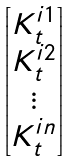Convert formula to latex. <formula><loc_0><loc_0><loc_500><loc_500>\begin{bmatrix} K ^ { i 1 } _ { t } \\ K ^ { i 2 } _ { t } \\ \vdots \\ K ^ { i n } _ { t } \end{bmatrix}</formula> 